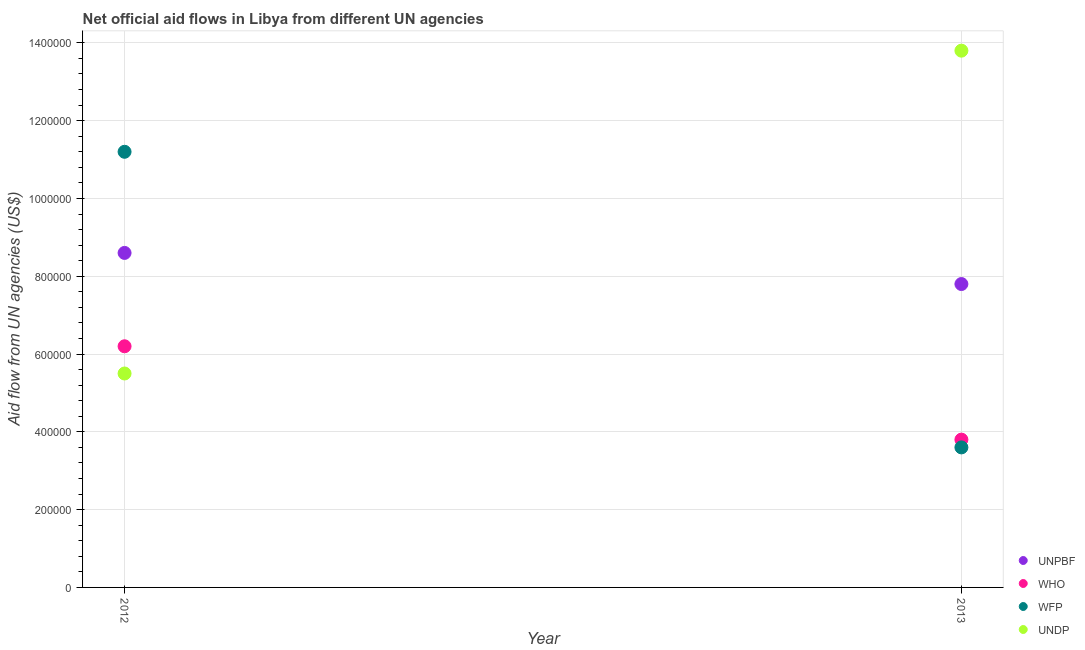What is the amount of aid given by who in 2013?
Your answer should be compact. 3.80e+05. Across all years, what is the maximum amount of aid given by who?
Your response must be concise. 6.20e+05. Across all years, what is the minimum amount of aid given by undp?
Keep it short and to the point. 5.50e+05. In which year was the amount of aid given by unpbf maximum?
Give a very brief answer. 2012. What is the total amount of aid given by undp in the graph?
Your answer should be compact. 1.93e+06. What is the difference between the amount of aid given by unpbf in 2012 and that in 2013?
Give a very brief answer. 8.00e+04. What is the difference between the amount of aid given by unpbf in 2012 and the amount of aid given by who in 2013?
Offer a very short reply. 4.80e+05. What is the average amount of aid given by who per year?
Ensure brevity in your answer.  5.00e+05. In the year 2012, what is the difference between the amount of aid given by unpbf and amount of aid given by undp?
Make the answer very short. 3.10e+05. What is the ratio of the amount of aid given by wfp in 2012 to that in 2013?
Your answer should be compact. 3.11. Is the amount of aid given by wfp in 2012 less than that in 2013?
Your answer should be very brief. No. In how many years, is the amount of aid given by unpbf greater than the average amount of aid given by unpbf taken over all years?
Give a very brief answer. 1. Is it the case that in every year, the sum of the amount of aid given by who and amount of aid given by undp is greater than the sum of amount of aid given by unpbf and amount of aid given by wfp?
Offer a terse response. No. Is it the case that in every year, the sum of the amount of aid given by unpbf and amount of aid given by who is greater than the amount of aid given by wfp?
Provide a short and direct response. Yes. Does the amount of aid given by unpbf monotonically increase over the years?
Provide a succinct answer. No. How many dotlines are there?
Give a very brief answer. 4. What is the difference between two consecutive major ticks on the Y-axis?
Keep it short and to the point. 2.00e+05. Does the graph contain any zero values?
Keep it short and to the point. No. How many legend labels are there?
Keep it short and to the point. 4. How are the legend labels stacked?
Your answer should be very brief. Vertical. What is the title of the graph?
Your answer should be compact. Net official aid flows in Libya from different UN agencies. What is the label or title of the X-axis?
Provide a short and direct response. Year. What is the label or title of the Y-axis?
Give a very brief answer. Aid flow from UN agencies (US$). What is the Aid flow from UN agencies (US$) of UNPBF in 2012?
Provide a short and direct response. 8.60e+05. What is the Aid flow from UN agencies (US$) in WHO in 2012?
Offer a terse response. 6.20e+05. What is the Aid flow from UN agencies (US$) in WFP in 2012?
Your answer should be compact. 1.12e+06. What is the Aid flow from UN agencies (US$) of UNDP in 2012?
Offer a very short reply. 5.50e+05. What is the Aid flow from UN agencies (US$) in UNPBF in 2013?
Offer a very short reply. 7.80e+05. What is the Aid flow from UN agencies (US$) of WHO in 2013?
Your answer should be compact. 3.80e+05. What is the Aid flow from UN agencies (US$) in UNDP in 2013?
Ensure brevity in your answer.  1.38e+06. Across all years, what is the maximum Aid flow from UN agencies (US$) in UNPBF?
Your answer should be compact. 8.60e+05. Across all years, what is the maximum Aid flow from UN agencies (US$) in WHO?
Provide a short and direct response. 6.20e+05. Across all years, what is the maximum Aid flow from UN agencies (US$) in WFP?
Your response must be concise. 1.12e+06. Across all years, what is the maximum Aid flow from UN agencies (US$) in UNDP?
Make the answer very short. 1.38e+06. Across all years, what is the minimum Aid flow from UN agencies (US$) in UNPBF?
Your response must be concise. 7.80e+05. Across all years, what is the minimum Aid flow from UN agencies (US$) in UNDP?
Provide a succinct answer. 5.50e+05. What is the total Aid flow from UN agencies (US$) of UNPBF in the graph?
Offer a very short reply. 1.64e+06. What is the total Aid flow from UN agencies (US$) of WHO in the graph?
Provide a succinct answer. 1.00e+06. What is the total Aid flow from UN agencies (US$) of WFP in the graph?
Provide a short and direct response. 1.48e+06. What is the total Aid flow from UN agencies (US$) in UNDP in the graph?
Provide a short and direct response. 1.93e+06. What is the difference between the Aid flow from UN agencies (US$) in UNPBF in 2012 and that in 2013?
Your answer should be very brief. 8.00e+04. What is the difference between the Aid flow from UN agencies (US$) in WFP in 2012 and that in 2013?
Make the answer very short. 7.60e+05. What is the difference between the Aid flow from UN agencies (US$) of UNDP in 2012 and that in 2013?
Provide a short and direct response. -8.30e+05. What is the difference between the Aid flow from UN agencies (US$) of UNPBF in 2012 and the Aid flow from UN agencies (US$) of WHO in 2013?
Offer a terse response. 4.80e+05. What is the difference between the Aid flow from UN agencies (US$) of UNPBF in 2012 and the Aid flow from UN agencies (US$) of WFP in 2013?
Ensure brevity in your answer.  5.00e+05. What is the difference between the Aid flow from UN agencies (US$) in UNPBF in 2012 and the Aid flow from UN agencies (US$) in UNDP in 2013?
Provide a short and direct response. -5.20e+05. What is the difference between the Aid flow from UN agencies (US$) of WHO in 2012 and the Aid flow from UN agencies (US$) of UNDP in 2013?
Keep it short and to the point. -7.60e+05. What is the difference between the Aid flow from UN agencies (US$) in WFP in 2012 and the Aid flow from UN agencies (US$) in UNDP in 2013?
Provide a succinct answer. -2.60e+05. What is the average Aid flow from UN agencies (US$) in UNPBF per year?
Keep it short and to the point. 8.20e+05. What is the average Aid flow from UN agencies (US$) of WHO per year?
Your answer should be very brief. 5.00e+05. What is the average Aid flow from UN agencies (US$) of WFP per year?
Your answer should be compact. 7.40e+05. What is the average Aid flow from UN agencies (US$) in UNDP per year?
Your answer should be compact. 9.65e+05. In the year 2012, what is the difference between the Aid flow from UN agencies (US$) of UNPBF and Aid flow from UN agencies (US$) of WFP?
Offer a very short reply. -2.60e+05. In the year 2012, what is the difference between the Aid flow from UN agencies (US$) of WHO and Aid flow from UN agencies (US$) of WFP?
Provide a succinct answer. -5.00e+05. In the year 2012, what is the difference between the Aid flow from UN agencies (US$) of WHO and Aid flow from UN agencies (US$) of UNDP?
Offer a very short reply. 7.00e+04. In the year 2012, what is the difference between the Aid flow from UN agencies (US$) of WFP and Aid flow from UN agencies (US$) of UNDP?
Your response must be concise. 5.70e+05. In the year 2013, what is the difference between the Aid flow from UN agencies (US$) in UNPBF and Aid flow from UN agencies (US$) in WHO?
Your response must be concise. 4.00e+05. In the year 2013, what is the difference between the Aid flow from UN agencies (US$) in UNPBF and Aid flow from UN agencies (US$) in UNDP?
Provide a succinct answer. -6.00e+05. In the year 2013, what is the difference between the Aid flow from UN agencies (US$) of WFP and Aid flow from UN agencies (US$) of UNDP?
Your answer should be very brief. -1.02e+06. What is the ratio of the Aid flow from UN agencies (US$) in UNPBF in 2012 to that in 2013?
Make the answer very short. 1.1. What is the ratio of the Aid flow from UN agencies (US$) of WHO in 2012 to that in 2013?
Ensure brevity in your answer.  1.63. What is the ratio of the Aid flow from UN agencies (US$) of WFP in 2012 to that in 2013?
Give a very brief answer. 3.11. What is the ratio of the Aid flow from UN agencies (US$) in UNDP in 2012 to that in 2013?
Offer a very short reply. 0.4. What is the difference between the highest and the second highest Aid flow from UN agencies (US$) of WFP?
Provide a succinct answer. 7.60e+05. What is the difference between the highest and the second highest Aid flow from UN agencies (US$) in UNDP?
Ensure brevity in your answer.  8.30e+05. What is the difference between the highest and the lowest Aid flow from UN agencies (US$) in UNPBF?
Offer a terse response. 8.00e+04. What is the difference between the highest and the lowest Aid flow from UN agencies (US$) in WHO?
Provide a short and direct response. 2.40e+05. What is the difference between the highest and the lowest Aid flow from UN agencies (US$) in WFP?
Keep it short and to the point. 7.60e+05. What is the difference between the highest and the lowest Aid flow from UN agencies (US$) of UNDP?
Offer a terse response. 8.30e+05. 